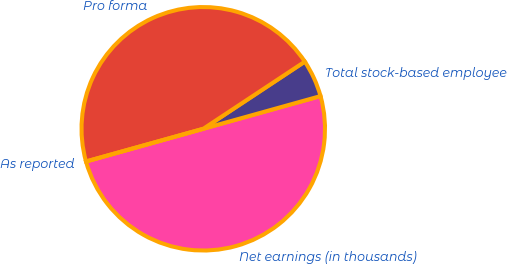Convert chart to OTSL. <chart><loc_0><loc_0><loc_500><loc_500><pie_chart><fcel>Net earnings (in thousands)<fcel>Total stock-based employee<fcel>Pro forma<fcel>As reported<nl><fcel>50.0%<fcel>4.97%<fcel>45.03%<fcel>0.0%<nl></chart> 